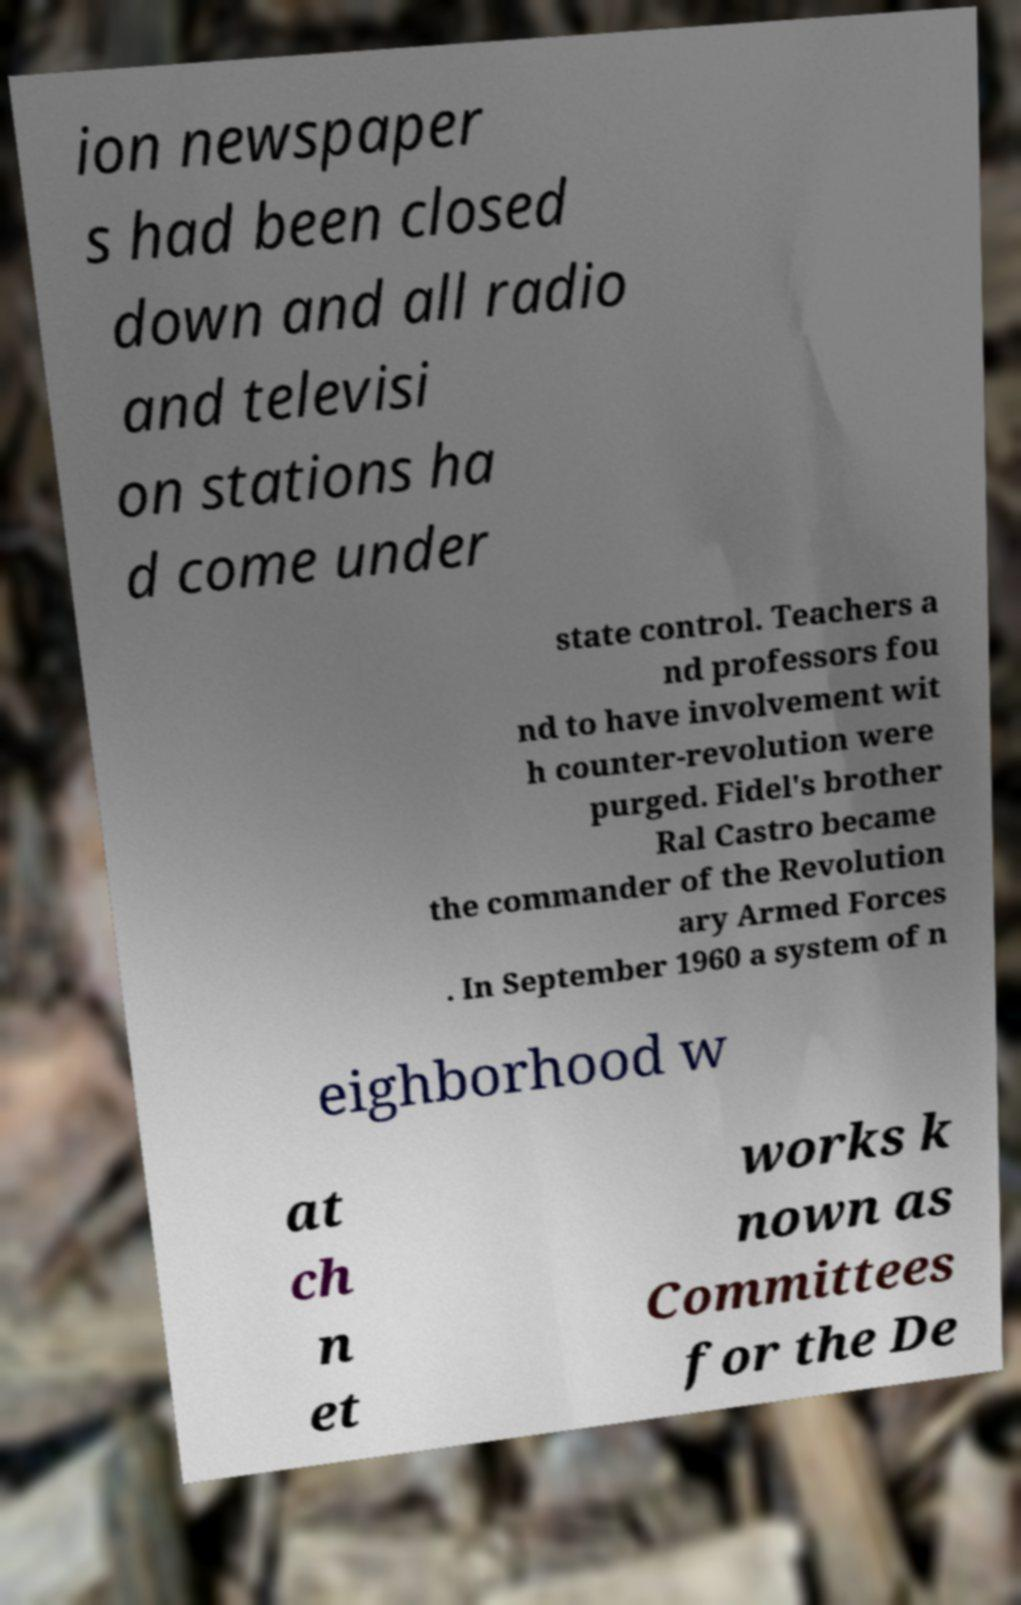What messages or text are displayed in this image? I need them in a readable, typed format. ion newspaper s had been closed down and all radio and televisi on stations ha d come under state control. Teachers a nd professors fou nd to have involvement wit h counter-revolution were purged. Fidel's brother Ral Castro became the commander of the Revolution ary Armed Forces . In September 1960 a system of n eighborhood w at ch n et works k nown as Committees for the De 